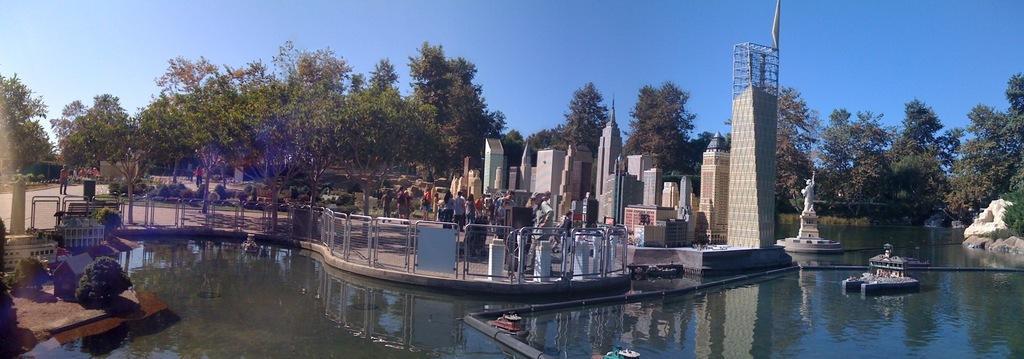Could you give a brief overview of what you see in this image? At the bottom there is water and we can see railings and there are buildings. We can see a sculpture. In the background there are trees and sky. We can see bushes. There are people. 